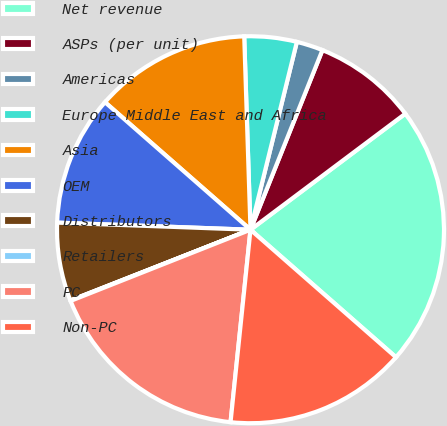<chart> <loc_0><loc_0><loc_500><loc_500><pie_chart><fcel>Net revenue<fcel>ASPs (per unit)<fcel>Americas<fcel>Europe Middle East and Africa<fcel>Asia<fcel>OEM<fcel>Distributors<fcel>Retailers<fcel>PC<fcel>Non-PC<nl><fcel>21.69%<fcel>8.7%<fcel>2.21%<fcel>4.37%<fcel>13.03%<fcel>10.87%<fcel>6.54%<fcel>0.04%<fcel>17.36%<fcel>15.19%<nl></chart> 